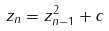Convert formula to latex. <formula><loc_0><loc_0><loc_500><loc_500>z _ { n } = z _ { n - 1 } ^ { 2 } + c</formula> 